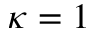<formula> <loc_0><loc_0><loc_500><loc_500>\kappa = 1</formula> 